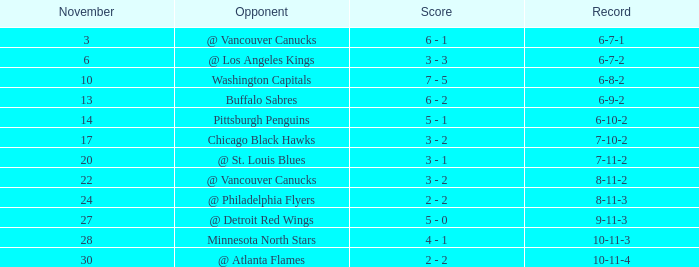Who is the opponent on november 24? @ Philadelphia Flyers. 